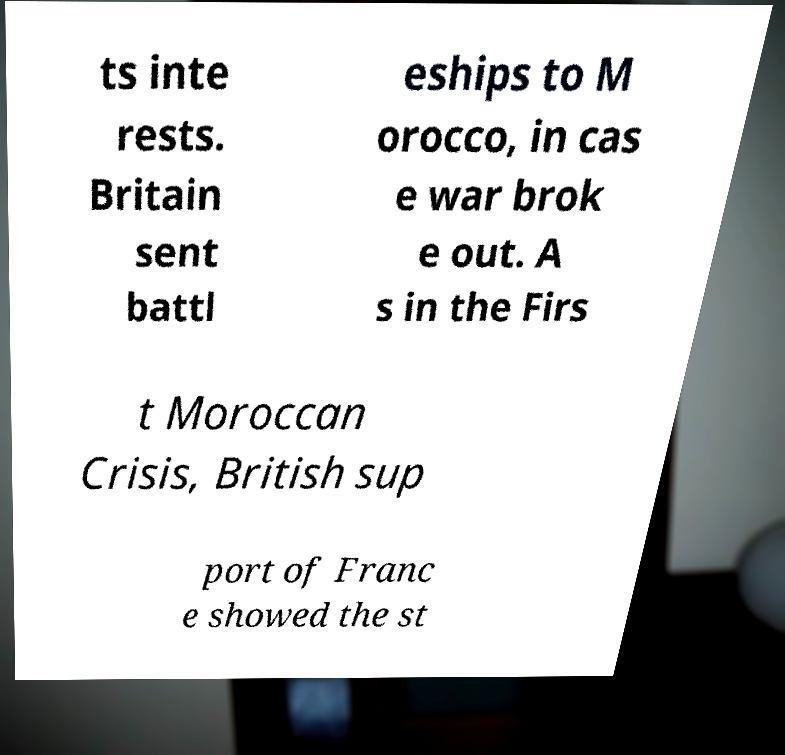What messages or text are displayed in this image? I need them in a readable, typed format. ts inte rests. Britain sent battl eships to M orocco, in cas e war brok e out. A s in the Firs t Moroccan Crisis, British sup port of Franc e showed the st 